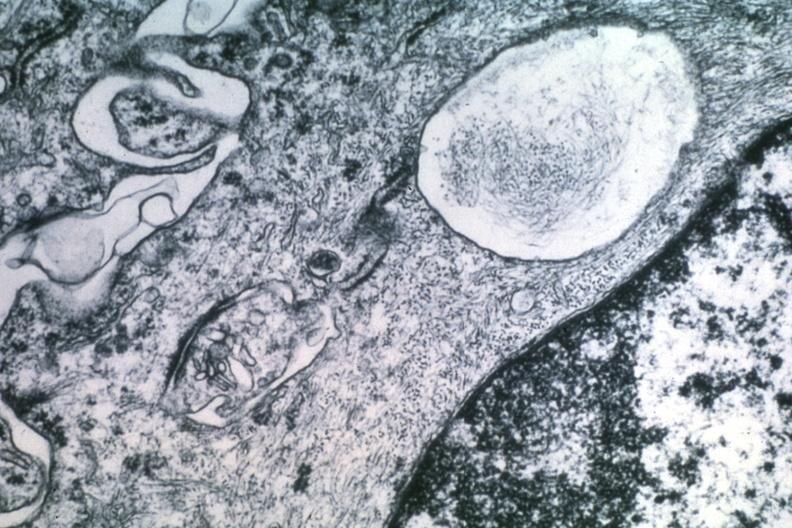does odontoid process subluxation with narrowing of foramen magnum show dr garcia tumors 47?
Answer the question using a single word or phrase. No 